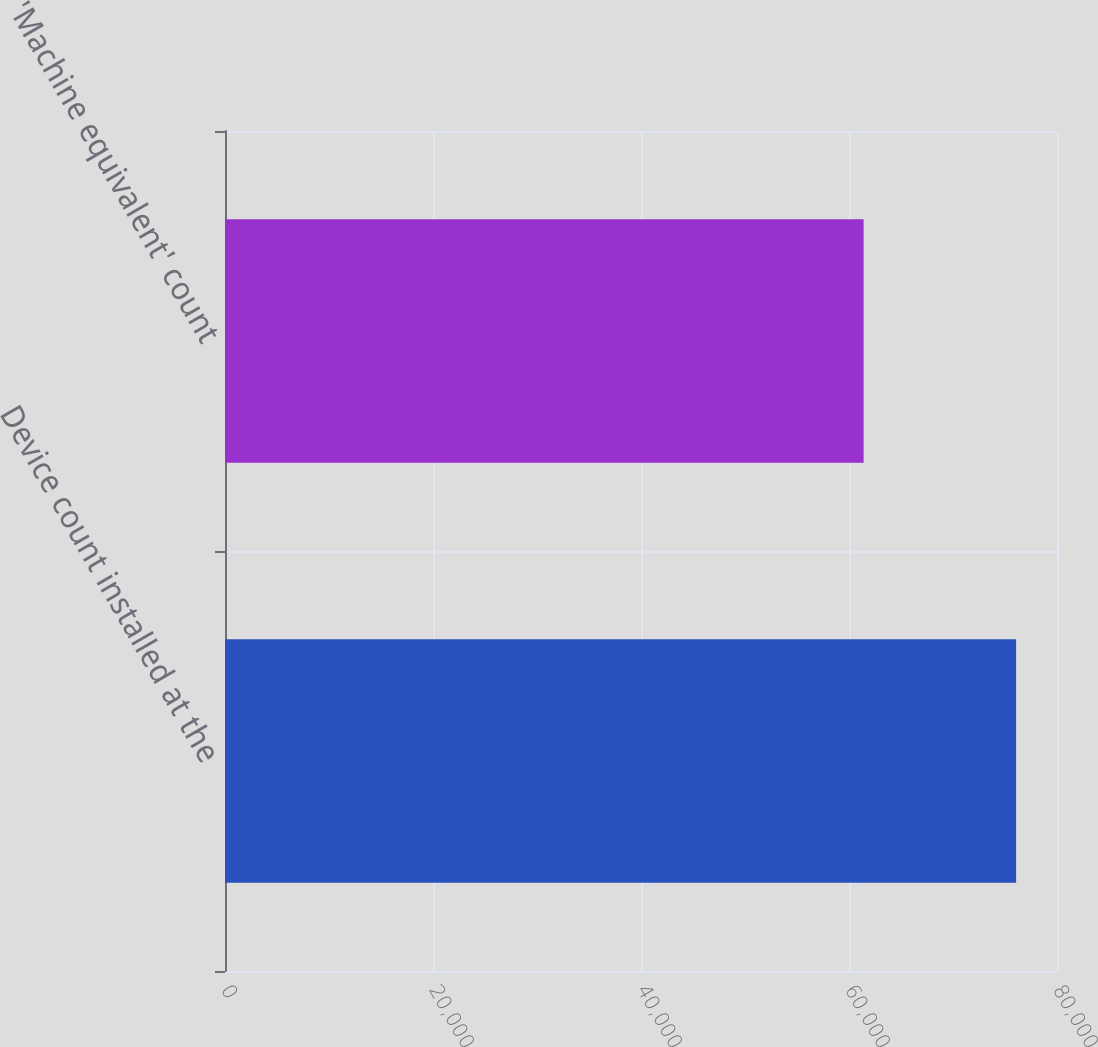<chart> <loc_0><loc_0><loc_500><loc_500><bar_chart><fcel>Device count installed at the<fcel>'Machine equivalent' count<nl><fcel>76069<fcel>61405<nl></chart> 